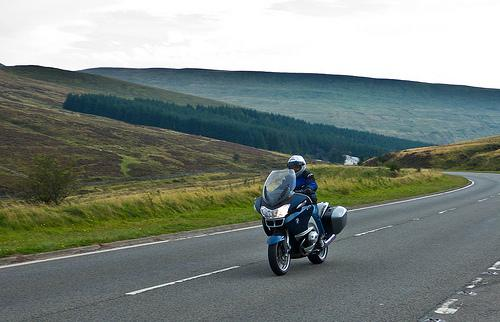Question: when during the day was this picture taken?
Choices:
A. At dusk.
B. Twilight.
C. Morning.
D. Daytime.
Answer with the letter. Answer: D Question: where was this picture taken?
Choices:
A. On a road.
B. In the kitchen.
C. At the airport.
D. In Europe.
Answer with the letter. Answer: A Question: what color is this person's jacket?
Choices:
A. Orange.
B. Pink.
C. Purple.
D. Blue and Black.
Answer with the letter. Answer: D 